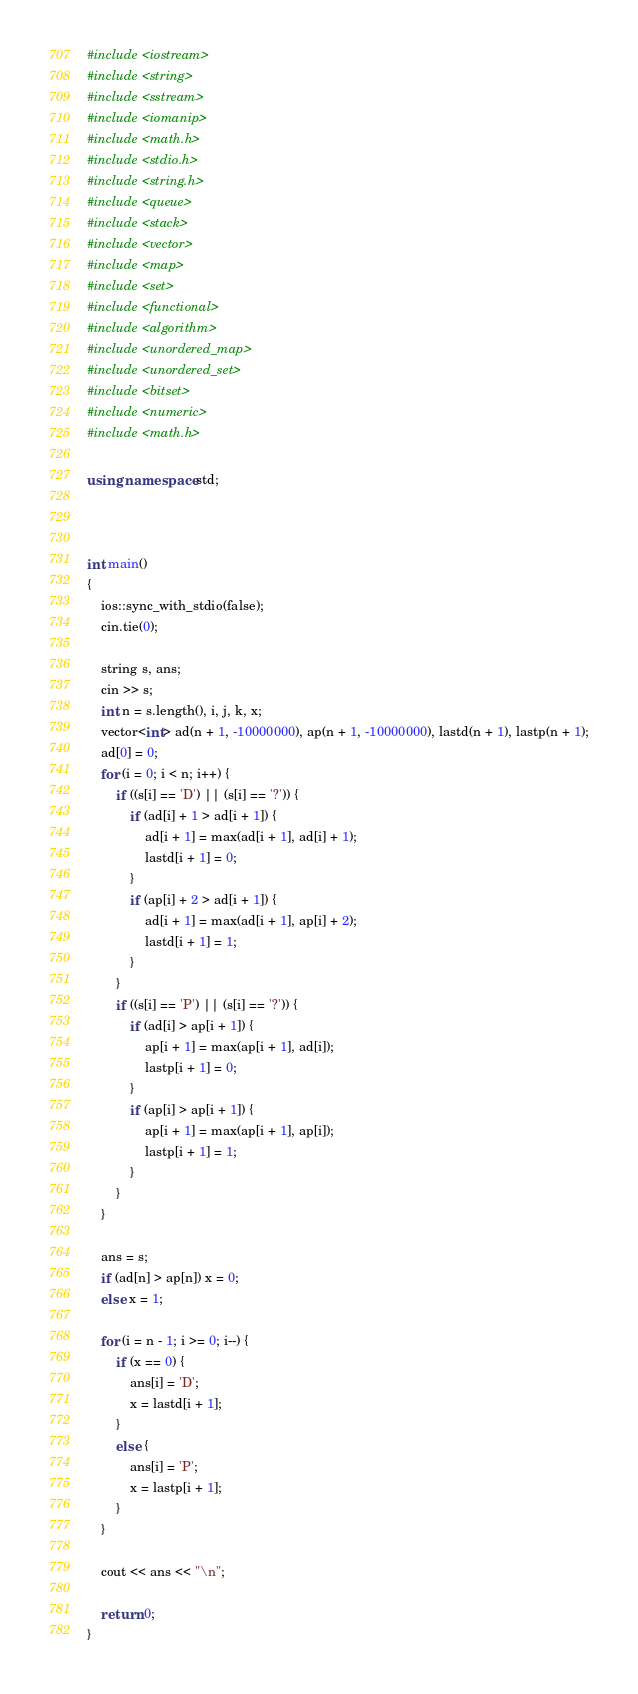<code> <loc_0><loc_0><loc_500><loc_500><_C++_>#include <iostream>
#include <string>
#include <sstream>
#include <iomanip> 
#include <math.h>
#include <stdio.h>
#include <string.h>
#include <queue>
#include <stack>
#include <vector>
#include <map>
#include <set>
#include <functional>
#include <algorithm>
#include <unordered_map>
#include <unordered_set>
#include <bitset>
#include <numeric>
#include <math.h> 

using namespace std;



int main()
{
	ios::sync_with_stdio(false);
	cin.tie(0);

	string s, ans;
	cin >> s;
	int n = s.length(), i, j, k, x;
	vector<int> ad(n + 1, -10000000), ap(n + 1, -10000000), lastd(n + 1), lastp(n + 1);
	ad[0] = 0; 
	for (i = 0; i < n; i++) {
		if ((s[i] == 'D') || (s[i] == '?')) {
			if (ad[i] + 1 > ad[i + 1]) {
				ad[i + 1] = max(ad[i + 1], ad[i] + 1);
				lastd[i + 1] = 0;
			}
			if (ap[i] + 2 > ad[i + 1]) {
				ad[i + 1] = max(ad[i + 1], ap[i] + 2);
				lastd[i + 1] = 1;
			}
		}
		if ((s[i] == 'P') || (s[i] == '?')) {
			if (ad[i] > ap[i + 1]) {
				ap[i + 1] = max(ap[i + 1], ad[i]);
				lastp[i + 1] = 0;
			}
			if (ap[i] > ap[i + 1]) {
				ap[i + 1] = max(ap[i + 1], ap[i]);
				lastp[i + 1] = 1;
			}
		}
	}

	ans = s;
	if (ad[n] > ap[n]) x = 0;
	else x = 1;

	for (i = n - 1; i >= 0; i--) {
		if (x == 0) {
			ans[i] = 'D';
			x = lastd[i + 1];
		}
		else {
			ans[i] = 'P';
			x = lastp[i + 1];
		}
	}

	cout << ans << "\n";

	return 0;
}

</code> 